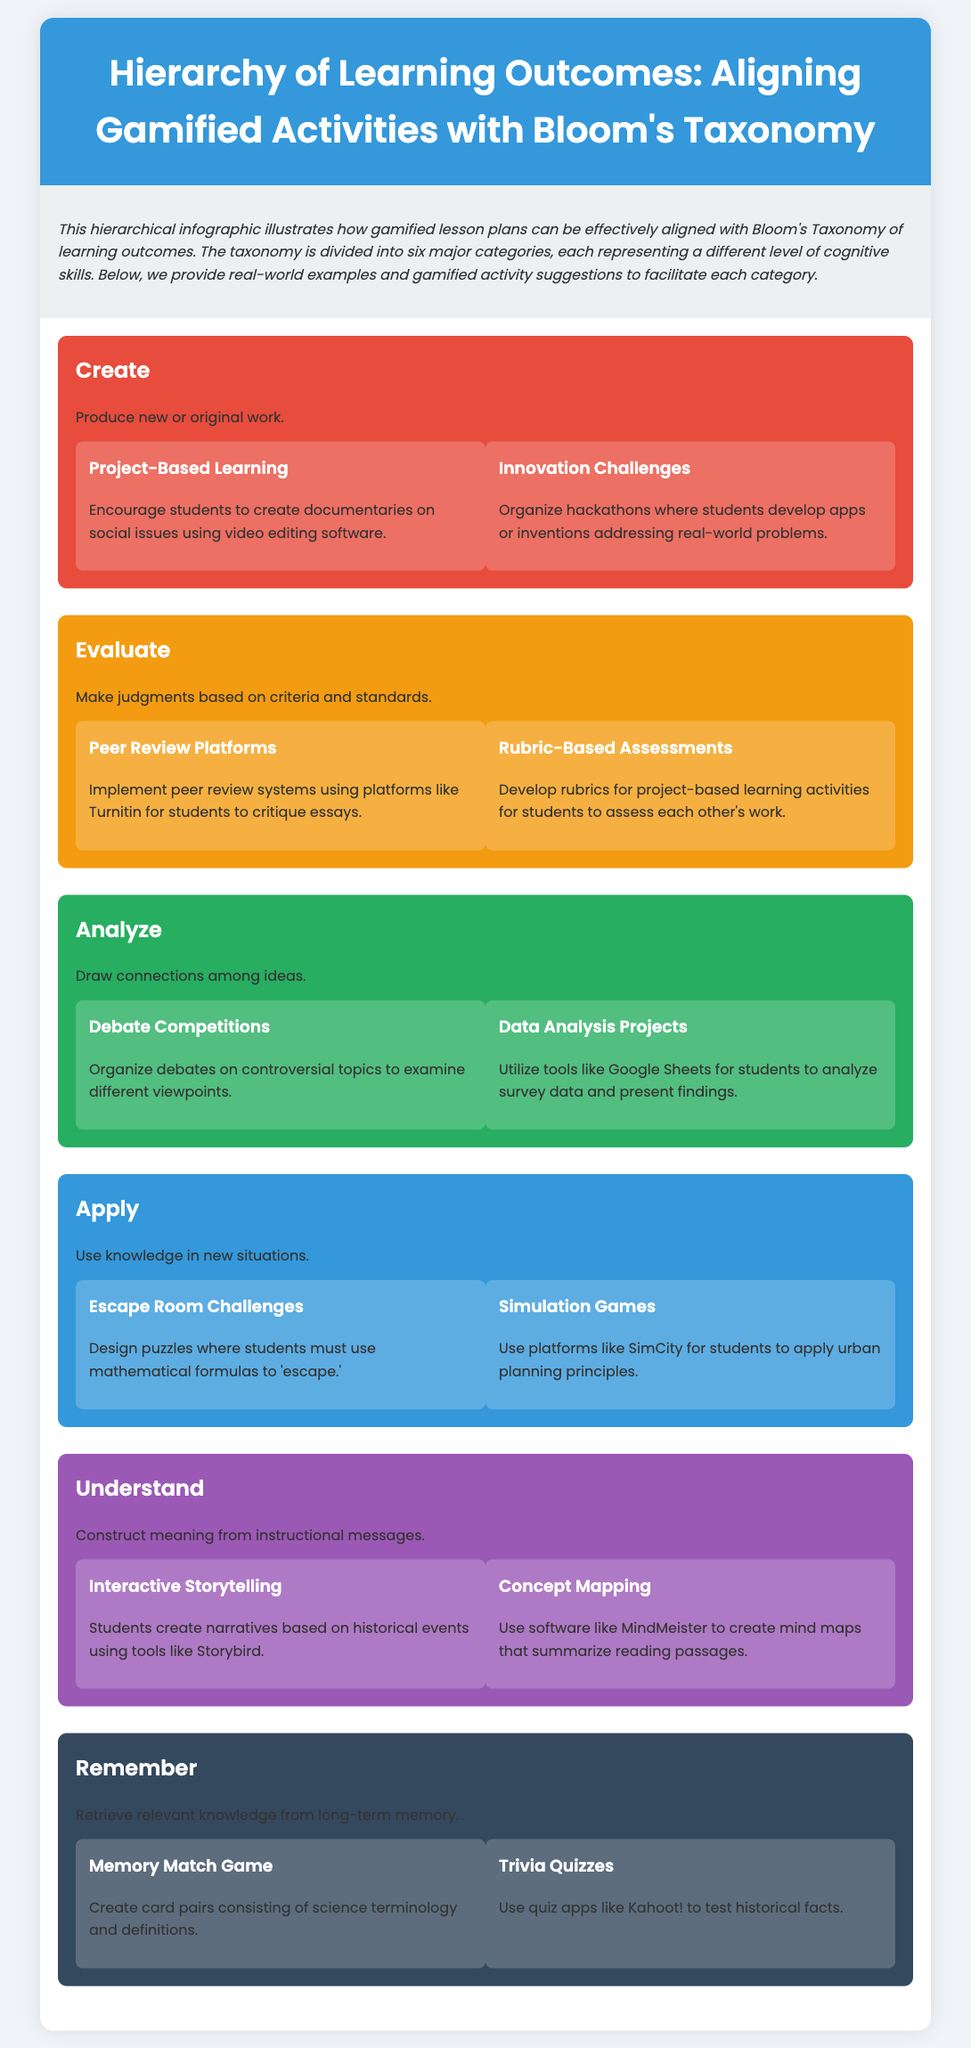What is the title of the infographic? The title of the infographic is provided at the top and summarizes the content focus on learning outcomes and Bloom's Taxonomy.
Answer: Hierarchy of Learning Outcomes: Aligning Gamified Activities with Bloom's Taxonomy How many levels are in the hierarchy? The document outlines six distinct levels of cognitive skills aligned with Bloom's Taxonomy.
Answer: Six What color represents the "Evaluate" level? Each level of the hierarchy is assigned a specific background color; the "Evaluate" level has its own unique color noted in the styling.
Answer: Orange What is an example of an activity under the "Create" level? The document provides activities for each level, and one is specifically mentioned under the "Create" category highlighting a project.
Answer: Project-Based Learning Which Bloom's Taxonomy level involves "using knowledge in new situations"? Each level is defined by a specific action related to cognitive processes, and this particular level is described with clear terminology.
Answer: Apply What is one tool mentioned for "Analyzing" data? The document suggests certain tools for specific activities under each level, including one for the analysis process described in the "Analyze" category.
Answer: Google Sheets How does the "Remember" level facilitate knowledge retrieval? The activities listed under this level are designed to enhance memory through specific gamified methods illustrated in the document.
Answer: Memory Match Game What does the "Understand" level focus on? This level emphasizes constructing meaning and comprehension based on the instructional messages provided in the lesson plans.
Answer: Construct meaning What are students encouraged to do in the "Interactive Storytelling" activity? The document outlines what students create under this activity, linking it to historical knowledge in a creative format.
Answer: Create narratives based on historical events 